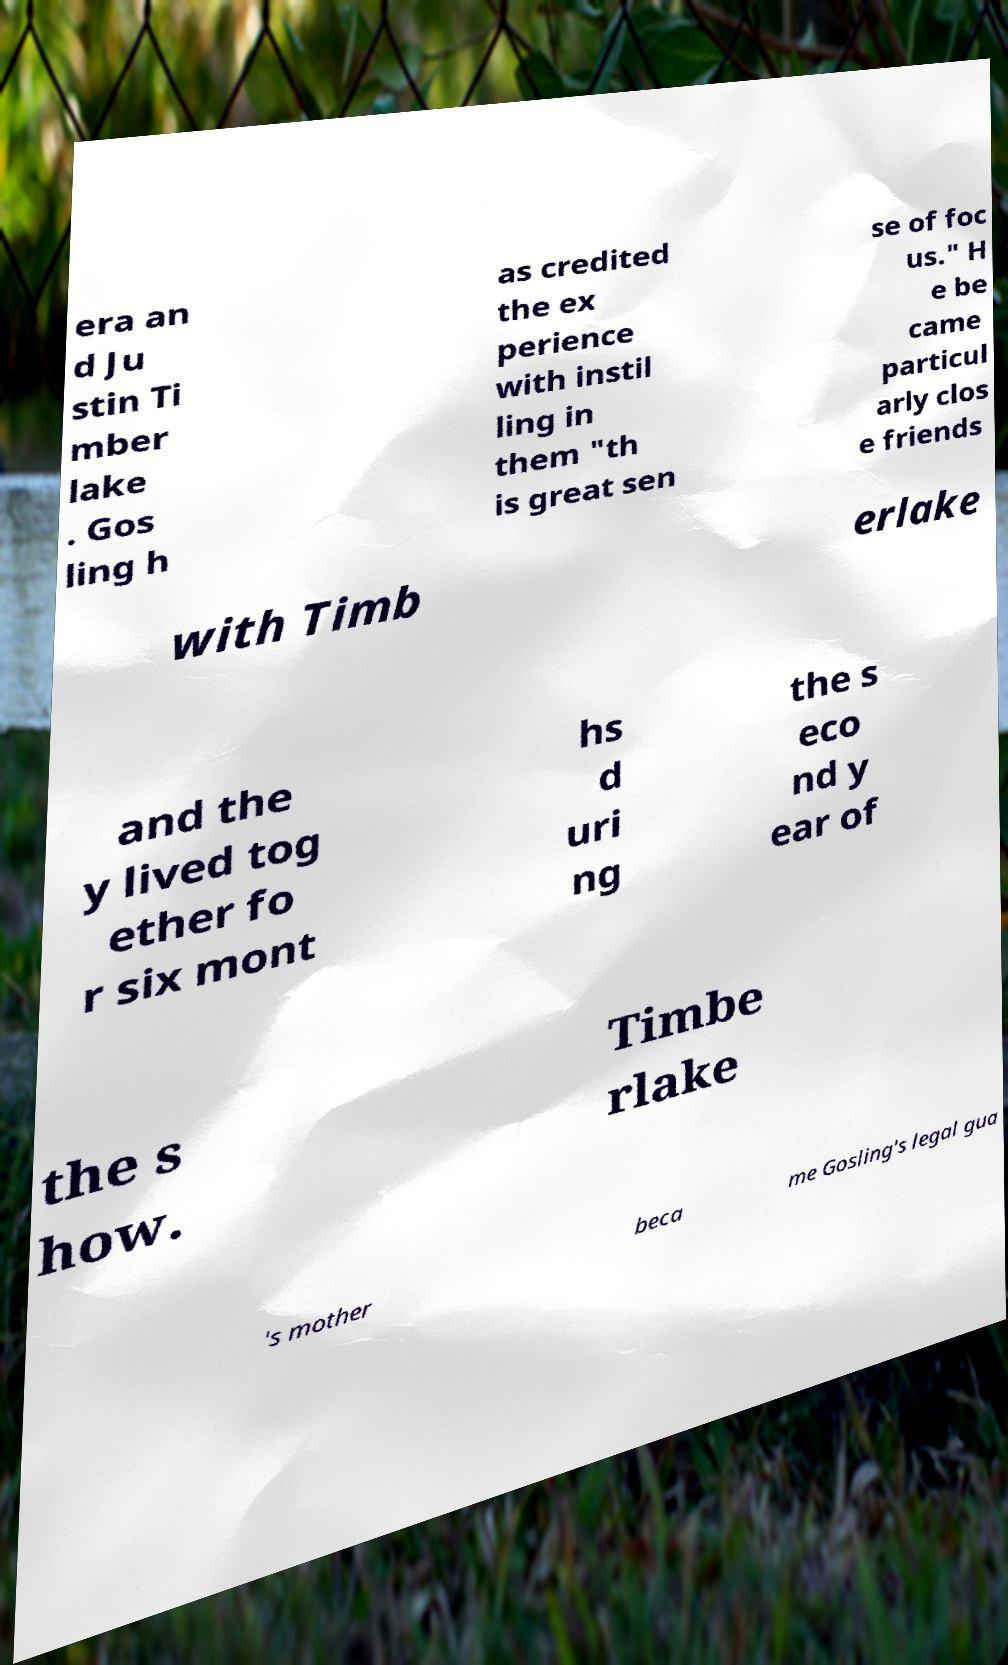Can you read and provide the text displayed in the image?This photo seems to have some interesting text. Can you extract and type it out for me? era an d Ju stin Ti mber lake . Gos ling h as credited the ex perience with instil ling in them "th is great sen se of foc us." H e be came particul arly clos e friends with Timb erlake and the y lived tog ether fo r six mont hs d uri ng the s eco nd y ear of the s how. Timbe rlake 's mother beca me Gosling's legal gua 